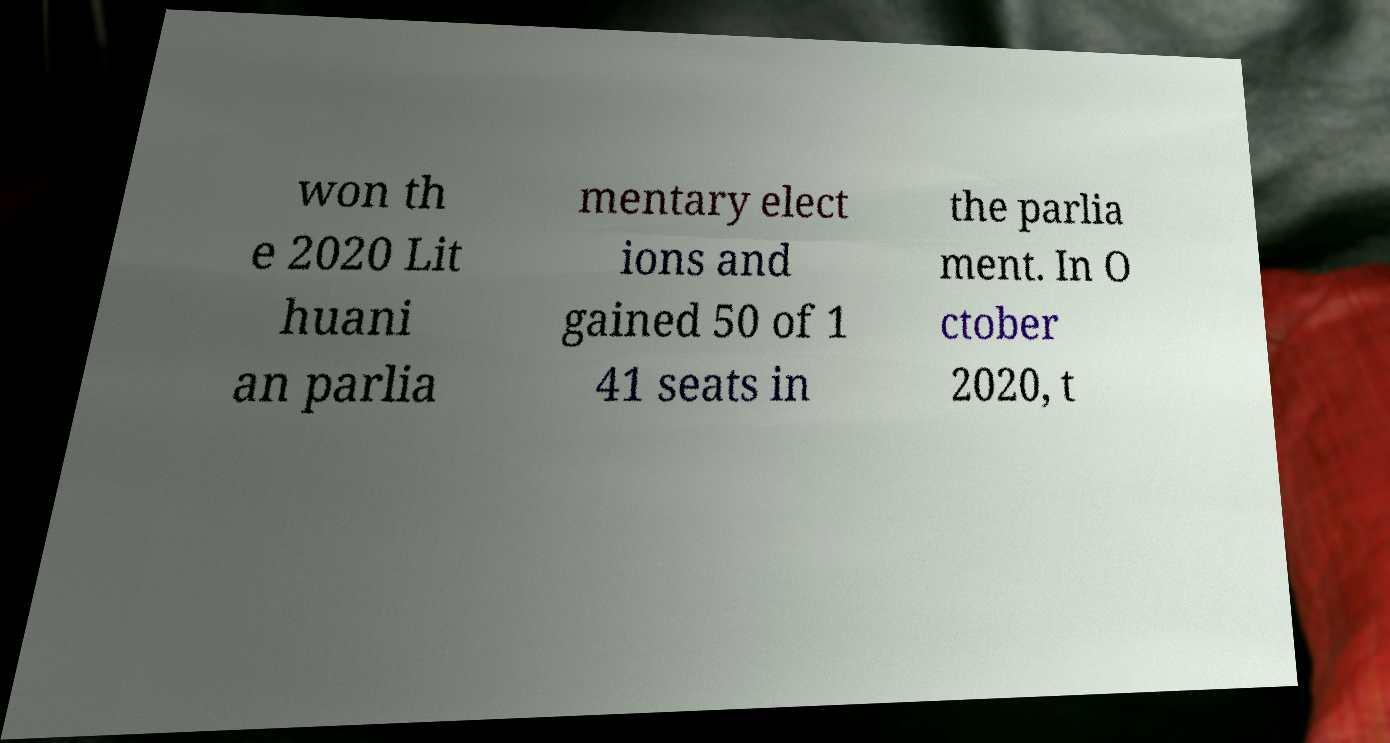Please read and relay the text visible in this image. What does it say? won th e 2020 Lit huani an parlia mentary elect ions and gained 50 of 1 41 seats in the parlia ment. In O ctober 2020, t 